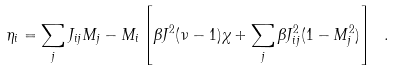<formula> <loc_0><loc_0><loc_500><loc_500>\eta _ { i } = \sum _ { j } J _ { i j } M _ { j } - M _ { i } \left [ \beta J ^ { 2 } ( \nu - 1 ) \chi + \sum _ { j } \beta J _ { i j } ^ { 2 } ( 1 - M _ { j } ^ { 2 } ) \right ] \ .</formula> 